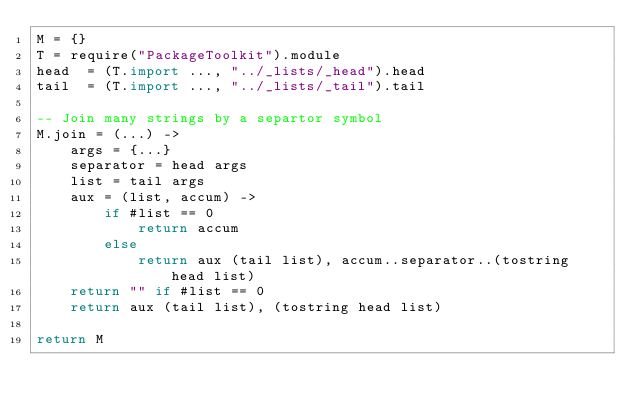Convert code to text. <code><loc_0><loc_0><loc_500><loc_500><_MoonScript_>M = {}
T = require("PackageToolkit").module
head  = (T.import ..., "../_lists/_head").head
tail  = (T.import ..., "../_lists/_tail").tail

-- Join many strings by a separtor symbol
M.join = (...) ->
    args = {...}
    separator = head args
    list = tail args
    aux = (list, accum) ->
        if #list == 0
            return accum
        else
            return aux (tail list), accum..separator..(tostring head list)
    return "" if #list == 0 
    return aux (tail list), (tostring head list)

return M</code> 